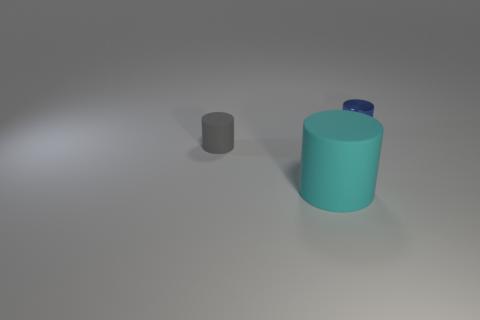Are there any other things that have the same size as the cyan object?
Give a very brief answer. No. Is there a big purple cube that has the same material as the cyan thing?
Your answer should be very brief. No. Do the tiny blue thing and the tiny cylinder in front of the metallic cylinder have the same material?
Provide a short and direct response. No. What is the color of the other matte thing that is the same size as the blue object?
Provide a succinct answer. Gray. How big is the rubber cylinder to the right of the gray cylinder behind the cyan thing?
Provide a short and direct response. Large. Do the metallic thing and the tiny object that is to the left of the metal object have the same color?
Ensure brevity in your answer.  No. Are there fewer cyan things on the right side of the small gray rubber object than small red metal objects?
Your answer should be very brief. No. How many other things are the same size as the blue object?
Provide a short and direct response. 1. Is the shape of the object that is on the right side of the large rubber thing the same as  the cyan matte thing?
Make the answer very short. Yes. Is the number of big cyan matte cylinders that are behind the tiny blue metal thing greater than the number of large green metallic cubes?
Keep it short and to the point. No. 